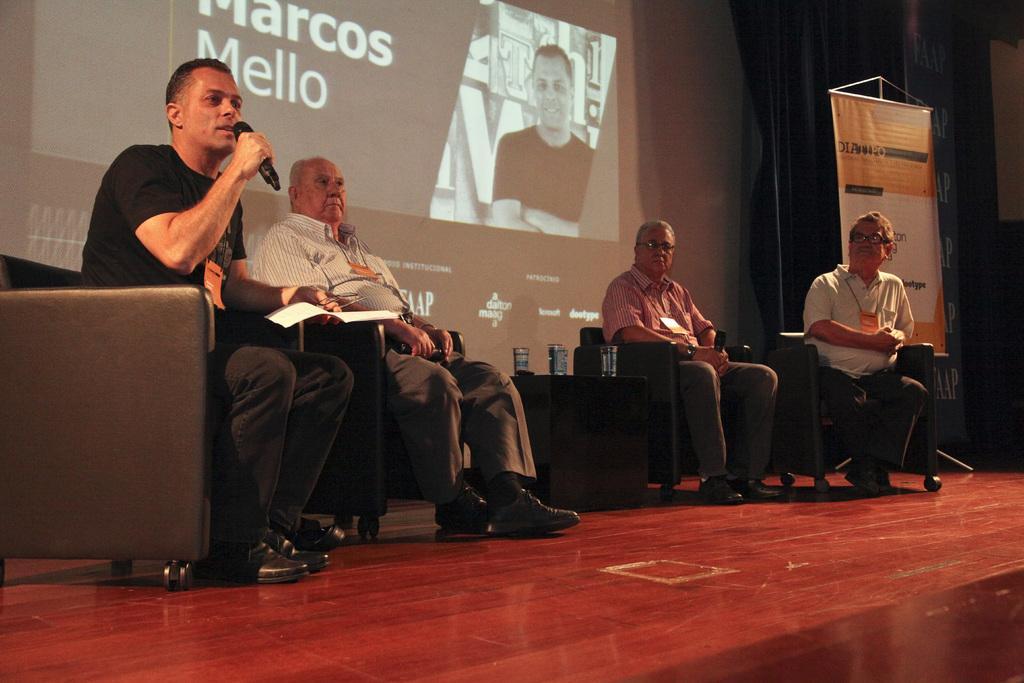How would you summarize this image in a sentence or two? In this image, we can see some people sitting on the chair and in the background, there is a screen and one of them is holding a mic. At the bottom, there is stage. 